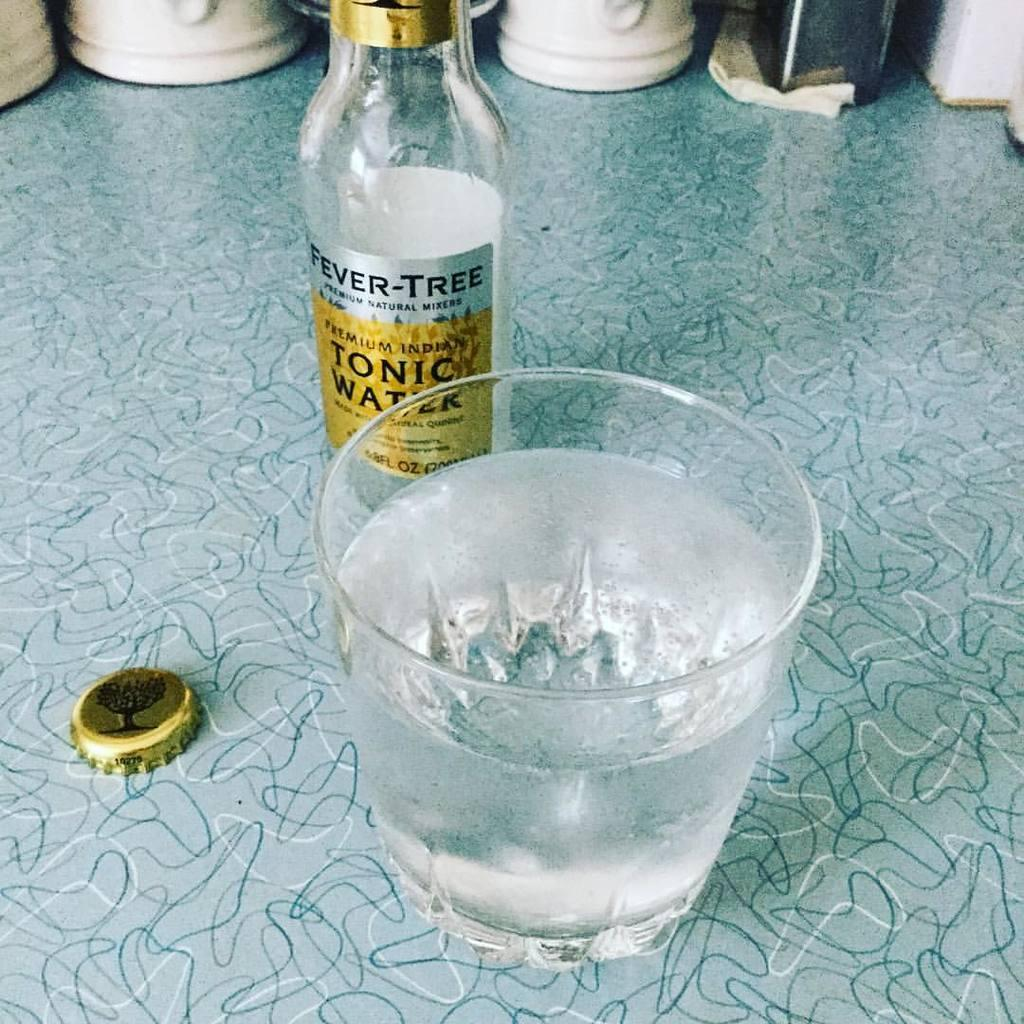<image>
Describe the image concisely. Bottle of Fever-Tree alcohol next to a cup of alcohol. 